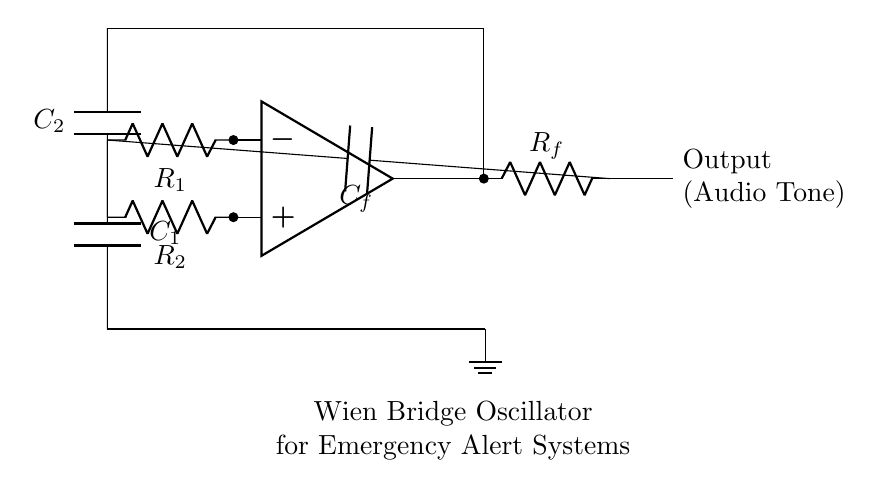What type of oscillator is depicted in the circuit? The circuit shown is a Wien bridge oscillator, which is characterized by its use of resistors and capacitors to generate sinusoidal waveforms. The presence of two resistors and two capacitors in a feedback loop confirms this.
Answer: Wien bridge oscillator What components are used for audio tone generation? The audio tone generation in this circuit involves an operational amplifier, resistors R1, R2, Rf, and capacitors C1, C2, and Cf. Together, these components form the feedback and frequency-determining elements necessary for oscillation.
Answer: Operational amplifier, resistors, capacitors How many capacitors are in this circuit? There are three capacitors labeled C1, C2, and Cf in the circuit. Each capacitor plays a role in the oscillation frequency and stability of the Wien bridge oscillator.
Answer: Three What does the output of the circuit represent? The output represents an audio tone, which is the result of the oscillation produced by the circuit. The output is taken directly from the output node and is indicated as "Audio Tone" in the diagram.
Answer: Audio tone Why is feedback important in this oscillator? Feedback is critical in oscillators to amplify the signal and sustain oscillation. In the Wien bridge oscillator, positive and negative feedback created by resistors and capacitors allows it to reach a stable oscillation state.
Answer: To sustain oscillation What is the role of resistor Rf in the circuit? Resistor Rf is a feedback resistor that regulates the gain of the amplifier. It ensures the correct amount of feedback to maintain consistent oscillation by adjusting the balance between the gain and attenuation in the circuit.
Answer: Regulate gain What is the primary function of the Wien bridge oscillator design? The primary function of the Wien bridge oscillator is to generate a stable sinusoidal signal, which can be used for various applications, including audio tone generation in emergency alert systems.
Answer: Generate audio tones 